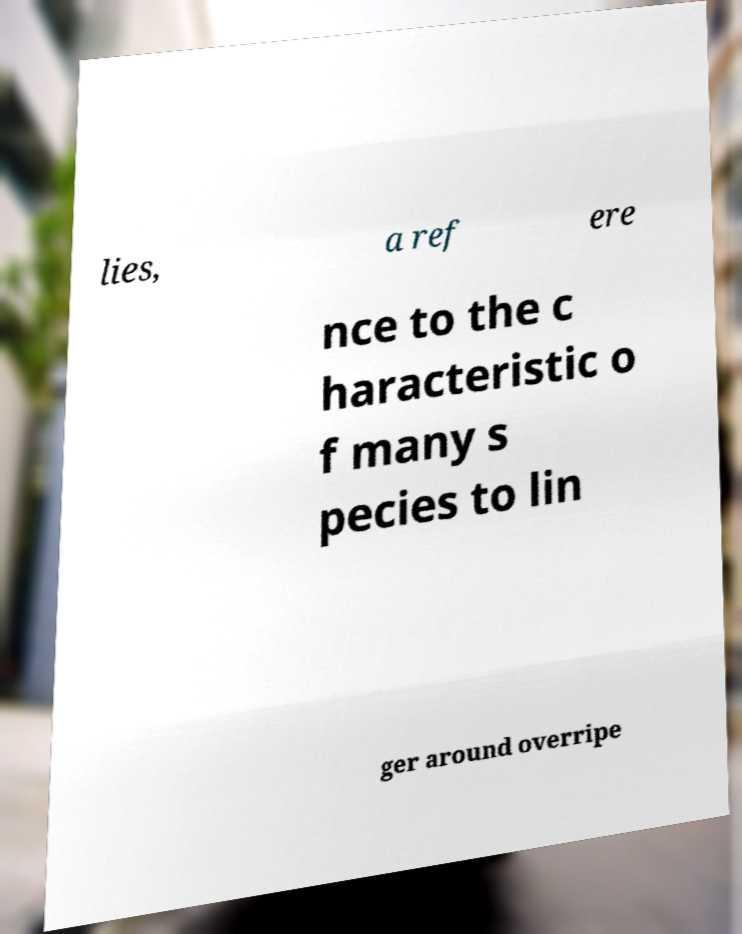Can you accurately transcribe the text from the provided image for me? lies, a ref ere nce to the c haracteristic o f many s pecies to lin ger around overripe 